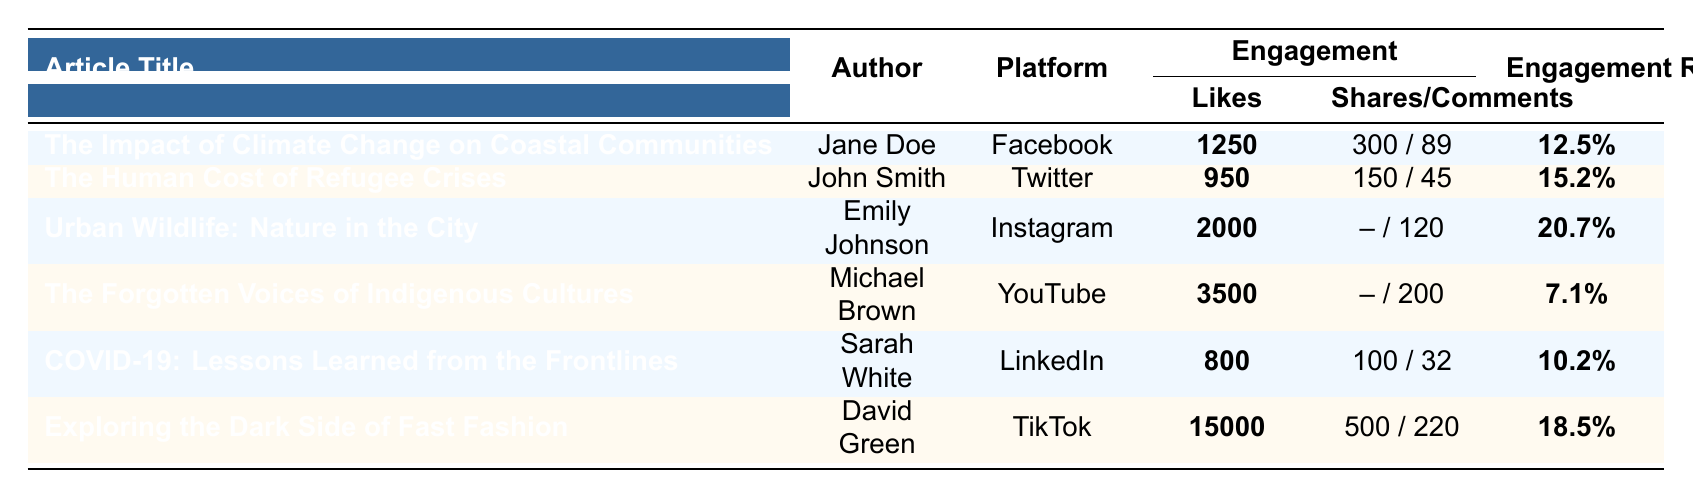What is the total number of likes across all articles? To find the total likes, I will sum the likes for each article: 1250 (Climate Change) + 950 (Refugee Crises) + 2000 (Urban Wildlife) + 3500 (Indigenous Cultures) + 800 (COVID-19) + 15000 (Fast Fashion) = 21000
Answer: 21000 Which article has the highest engagement rate? By comparing the engagement rates listed for each article, Urban Wildlife has the highest at 20.7%.
Answer: Urban Wildlife: Nature in the City How many articles had more than 1000 likes? I will count the articles with likes greater than 1000: Urban Wildlife (2000), The Forgotten Voices (3500), and Exploring the Dark Side (15000) which totals 3 articles.
Answer: 3 Is the engagement rate of "The Forgotten Voices of Indigenous Cultures" higher than 10%? The engagement rate for this article is 7.1%, which is lower than 10%.
Answer: No What is the average number of shares for articles across all platforms? To find the average, I will consider only articles with shares: (300 (Climate Change) + 150 (Refugee Crises) + 500 (Fast Fashion)) = 950 shares from 3 articles. The average is 950/3 = 316.67.
Answer: 316.67 Did “COVID-19: Lessons Learned from the Frontlines” receive more comments than “The Human Cost of Refugee Crises”? COVID-19 received 32 comments and Human Cost received 45 comments, so COVID-19 received fewer comments.
Answer: No What are the likes and shares/comments for the article with the lowest engagement rate? The article with the lowest engagement rate is "The Forgotten Voices of Indigenous Cultures" with 3500 likes and 200 comments.
Answer: 3500 likes, 200 comments What is the difference in the number of likes between the articles "Urban Wildlife" and "Exploring the Dark Side of Fast Fashion"? Urban Wildlife has 2000 likes and Exploring the Dark Side has 15000 likes. The difference is 15000 - 2000 = 13000.
Answer: 13000 Which platform received the least likes overall? I will compare the likes: Facebook (1250), Twitter (950), Instagram (2000), YouTube (3500), LinkedIn (800), TikTok (15000). LinkedIn has the least with 800 likes.
Answer: LinkedIn Calculate the total engagement (likes, shares, and comments) for "The Impact of Climate Change on Coastal Communities." Total engagement for this article is calculated as: Likes (1250) + Shares (300) + Comments (89) = 1639.
Answer: 1639 